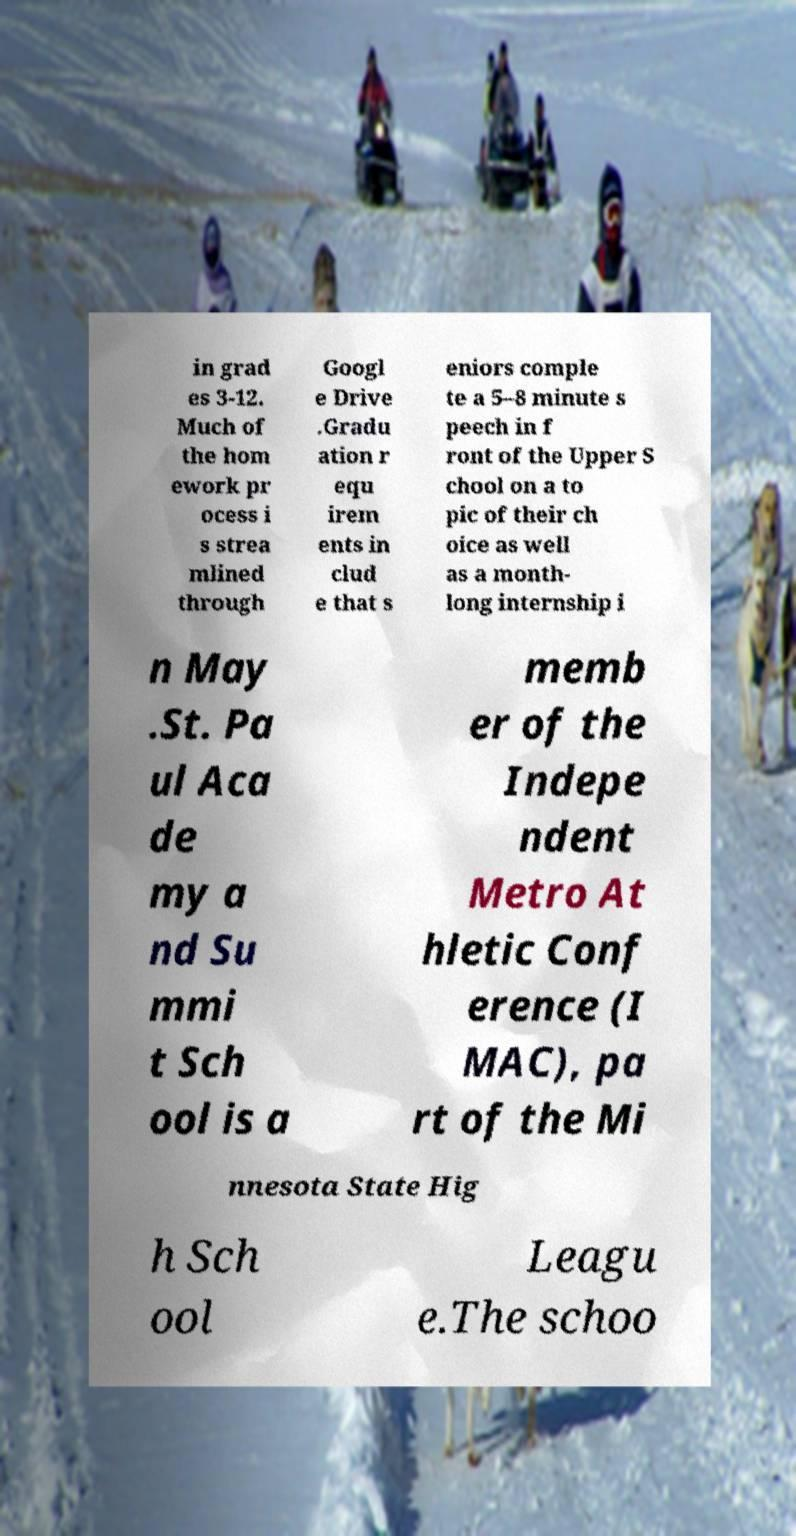I need the written content from this picture converted into text. Can you do that? in grad es 3-12. Much of the hom ework pr ocess i s strea mlined through Googl e Drive .Gradu ation r equ irem ents in clud e that s eniors comple te a 5–8 minute s peech in f ront of the Upper S chool on a to pic of their ch oice as well as a month- long internship i n May .St. Pa ul Aca de my a nd Su mmi t Sch ool is a memb er of the Indepe ndent Metro At hletic Conf erence (I MAC), pa rt of the Mi nnesota State Hig h Sch ool Leagu e.The schoo 